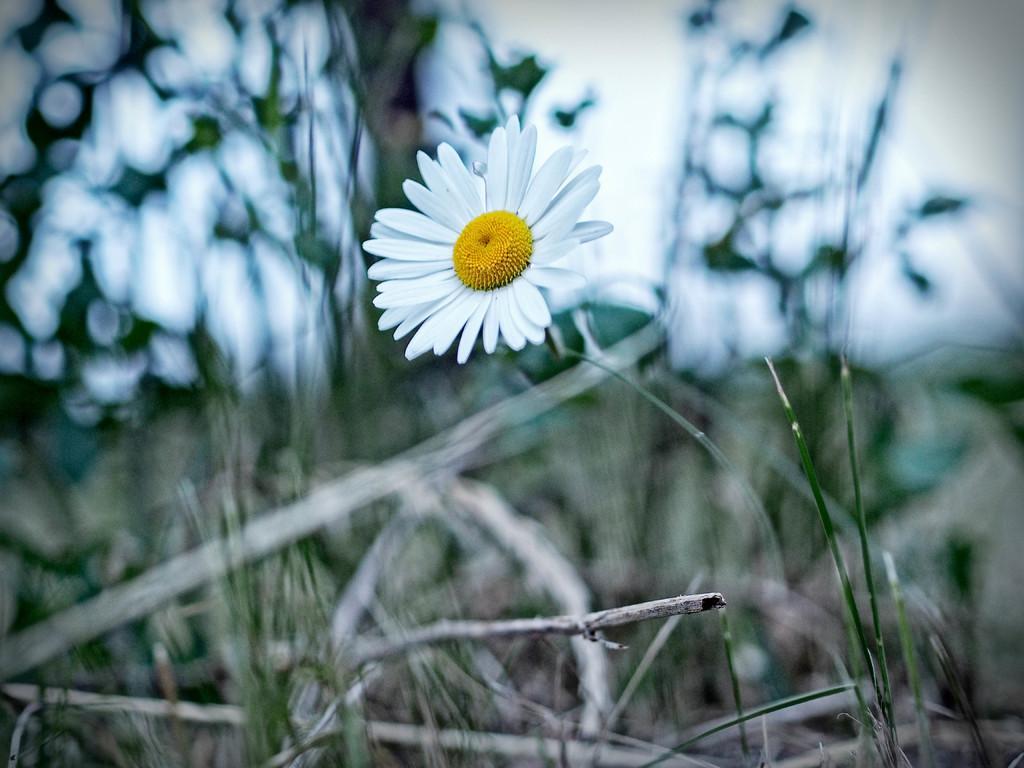In one or two sentences, can you explain what this image depicts? This picture is taken from outside of the city. In this image, in the middle, we can see a flower which is in white color. In the background, we can see some trees and plants. At the top, we can see a sky. 